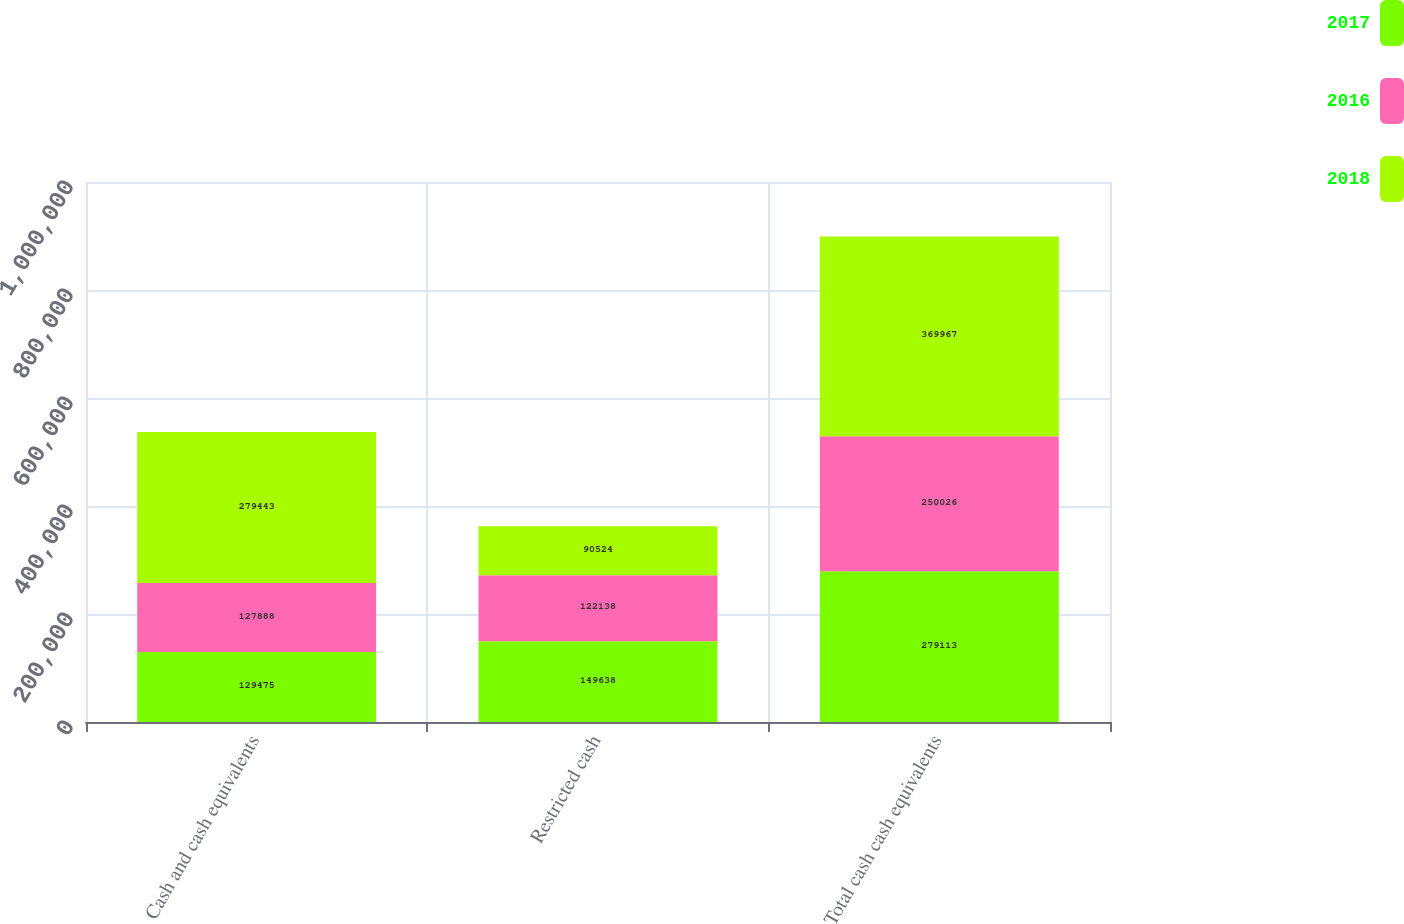<chart> <loc_0><loc_0><loc_500><loc_500><stacked_bar_chart><ecel><fcel>Cash and cash equivalents<fcel>Restricted cash<fcel>Total cash cash equivalents<nl><fcel>2017<fcel>129475<fcel>149638<fcel>279113<nl><fcel>2016<fcel>127888<fcel>122138<fcel>250026<nl><fcel>2018<fcel>279443<fcel>90524<fcel>369967<nl></chart> 